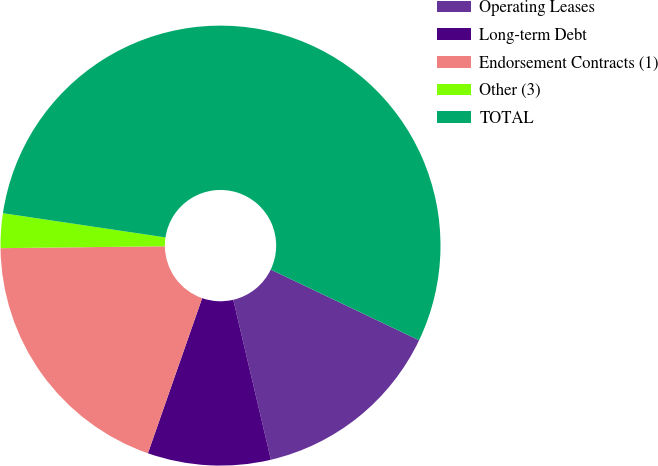Convert chart to OTSL. <chart><loc_0><loc_0><loc_500><loc_500><pie_chart><fcel>Operating Leases<fcel>Long-term Debt<fcel>Endorsement Contracts (1)<fcel>Other (3)<fcel>TOTAL<nl><fcel>14.24%<fcel>9.03%<fcel>19.46%<fcel>2.54%<fcel>54.72%<nl></chart> 